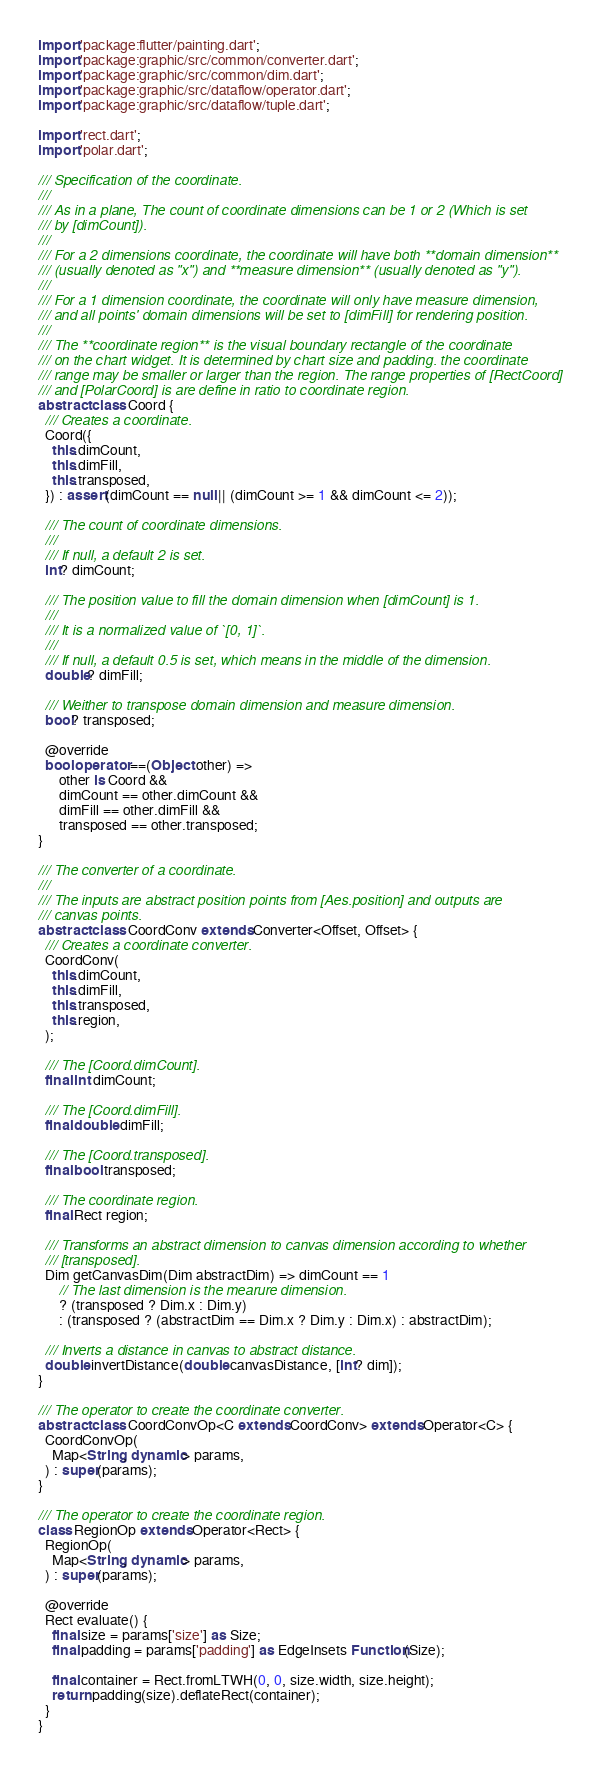Convert code to text. <code><loc_0><loc_0><loc_500><loc_500><_Dart_>import 'package:flutter/painting.dart';
import 'package:graphic/src/common/converter.dart';
import 'package:graphic/src/common/dim.dart';
import 'package:graphic/src/dataflow/operator.dart';
import 'package:graphic/src/dataflow/tuple.dart';

import 'rect.dart';
import 'polar.dart';

/// Specification of the coordinate.
///
/// As in a plane, The count of coordinate dimensions can be 1 or 2 (Which is set
/// by [dimCount]).
///
/// For a 2 dimensions coordinate, the coordinate will have both **domain dimension**
/// (usually denoted as "x") and **measure dimension** (usually denoted as "y").
///
/// For a 1 dimension coordinate, the coordinate will only have measure dimension,
/// and all points' domain dimensions will be set to [dimFill] for rendering position.
///
/// The **coordinate region** is the visual boundary rectangle of the coordinate
/// on the chart widget. It is determined by chart size and padding. the coordinate
/// range may be smaller or larger than the region. The range properties of [RectCoord]
/// and [PolarCoord] is are define in ratio to coordinate region.
abstract class Coord {
  /// Creates a coordinate.
  Coord({
    this.dimCount,
    this.dimFill,
    this.transposed,
  }) : assert(dimCount == null || (dimCount >= 1 && dimCount <= 2));

  /// The count of coordinate dimensions.
  ///
  /// If null, a default 2 is set.
  int? dimCount;

  /// The position value to fill the domain dimension when [dimCount] is 1.
  ///
  /// It is a normalized value of `[0, 1]`.
  ///
  /// If null, a default 0.5 is set, which means in the middle of the dimension.
  double? dimFill;

  /// Weither to transpose domain dimension and measure dimension.
  bool? transposed;

  @override
  bool operator ==(Object other) =>
      other is Coord &&
      dimCount == other.dimCount &&
      dimFill == other.dimFill &&
      transposed == other.transposed;
}

/// The converter of a coordinate.
///
/// The inputs are abstract position points from [Aes.position] and outputs are
/// canvas points.
abstract class CoordConv extends Converter<Offset, Offset> {
  /// Creates a coordinate converter.
  CoordConv(
    this.dimCount,
    this.dimFill,
    this.transposed,
    this.region,
  );

  /// The [Coord.dimCount].
  final int dimCount;

  /// The [Coord.dimFill].
  final double dimFill;

  /// The [Coord.transposed].
  final bool transposed;

  /// The coordinate region.
  final Rect region;

  /// Transforms an abstract dimension to canvas dimension according to whether
  /// [transposed].
  Dim getCanvasDim(Dim abstractDim) => dimCount == 1
      // The last dimension is the mearure dimension.
      ? (transposed ? Dim.x : Dim.y)
      : (transposed ? (abstractDim == Dim.x ? Dim.y : Dim.x) : abstractDim);

  /// Inverts a distance in canvas to abstract distance.
  double invertDistance(double canvasDistance, [int? dim]);
}

/// The operator to create the coordinate converter.
abstract class CoordConvOp<C extends CoordConv> extends Operator<C> {
  CoordConvOp(
    Map<String, dynamic> params,
  ) : super(params);
}

/// The operator to create the coordinate region.
class RegionOp extends Operator<Rect> {
  RegionOp(
    Map<String, dynamic> params,
  ) : super(params);

  @override
  Rect evaluate() {
    final size = params['size'] as Size;
    final padding = params['padding'] as EdgeInsets Function(Size);

    final container = Rect.fromLTWH(0, 0, size.width, size.height);
    return padding(size).deflateRect(container);
  }
}
</code> 